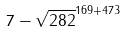Convert formula to latex. <formula><loc_0><loc_0><loc_500><loc_500>7 - \sqrt { 2 8 2 } ^ { 1 6 9 + 4 7 3 }</formula> 